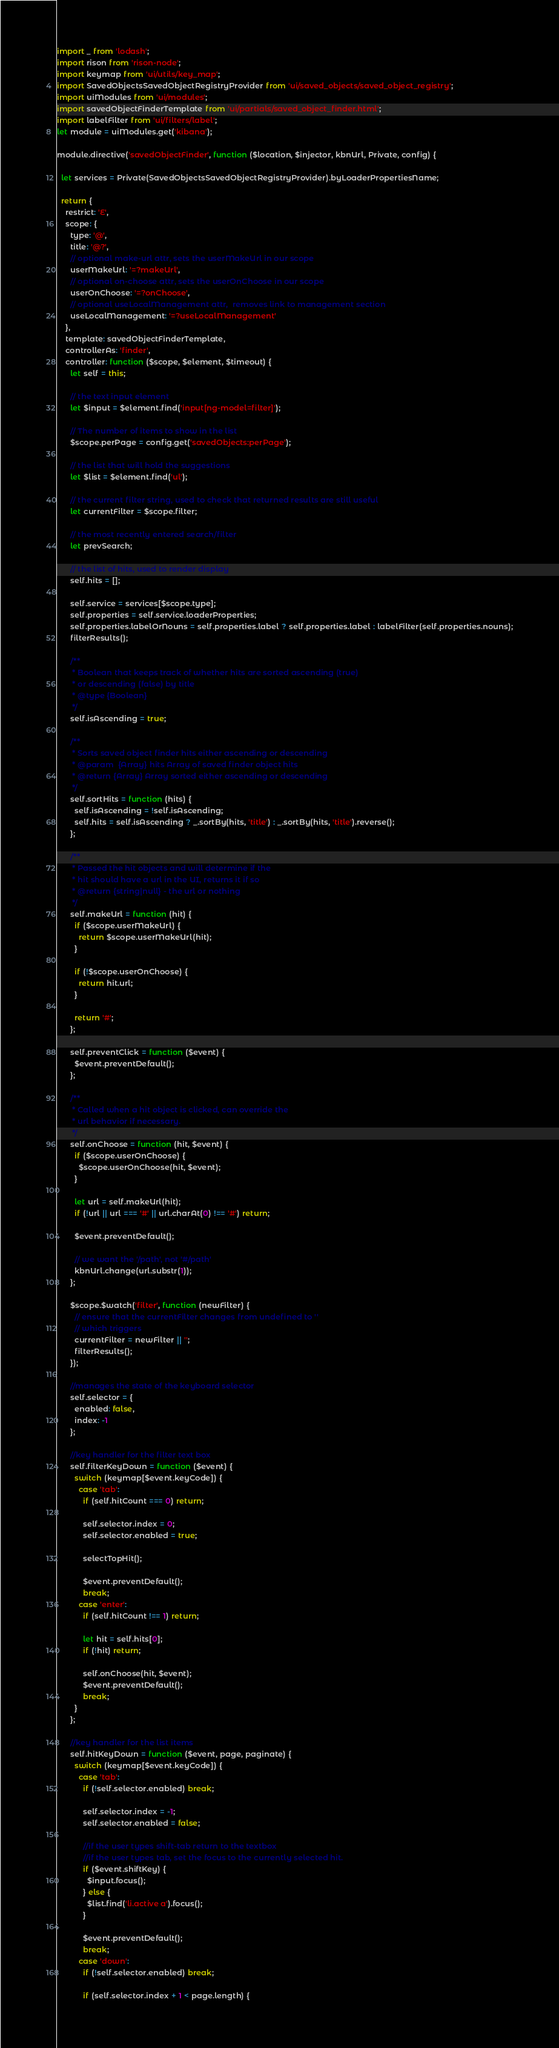<code> <loc_0><loc_0><loc_500><loc_500><_JavaScript_>import _ from 'lodash';
import rison from 'rison-node';
import keymap from 'ui/utils/key_map';
import SavedObjectsSavedObjectRegistryProvider from 'ui/saved_objects/saved_object_registry';
import uiModules from 'ui/modules';
import savedObjectFinderTemplate from 'ui/partials/saved_object_finder.html';
import labelFilter from 'ui/filters/label';
let module = uiModules.get('kibana');

module.directive('savedObjectFinder', function ($location, $injector, kbnUrl, Private, config) {

  let services = Private(SavedObjectsSavedObjectRegistryProvider).byLoaderPropertiesName;

  return {
    restrict: 'E',
    scope: {
      type: '@',
      title: '@?',
      // optional make-url attr, sets the userMakeUrl in our scope
      userMakeUrl: '=?makeUrl',
      // optional on-choose attr, sets the userOnChoose in our scope
      userOnChoose: '=?onChoose',
      // optional useLocalManagement attr,  removes link to management section
      useLocalManagement: '=?useLocalManagement'
    },
    template: savedObjectFinderTemplate,
    controllerAs: 'finder',
    controller: function ($scope, $element, $timeout) {
      let self = this;

      // the text input element
      let $input = $element.find('input[ng-model=filter]');

      // The number of items to show in the list
      $scope.perPage = config.get('savedObjects:perPage');

      // the list that will hold the suggestions
      let $list = $element.find('ul');

      // the current filter string, used to check that returned results are still useful
      let currentFilter = $scope.filter;

      // the most recently entered search/filter
      let prevSearch;

      // the list of hits, used to render display
      self.hits = [];

      self.service = services[$scope.type];
      self.properties = self.service.loaderProperties;
      self.properties.labelOrNouns = self.properties.label ? self.properties.label : labelFilter(self.properties.nouns);
      filterResults();

      /**
       * Boolean that keeps track of whether hits are sorted ascending (true)
       * or descending (false) by title
       * @type {Boolean}
       */
      self.isAscending = true;

      /**
       * Sorts saved object finder hits either ascending or descending
       * @param  {Array} hits Array of saved finder object hits
       * @return {Array} Array sorted either ascending or descending
       */
      self.sortHits = function (hits) {
        self.isAscending = !self.isAscending;
        self.hits = self.isAscending ? _.sortBy(hits, 'title') : _.sortBy(hits, 'title').reverse();
      };

      /**
       * Passed the hit objects and will determine if the
       * hit should have a url in the UI, returns it if so
       * @return {string|null} - the url or nothing
       */
      self.makeUrl = function (hit) {
        if ($scope.userMakeUrl) {
          return $scope.userMakeUrl(hit);
        }

        if (!$scope.userOnChoose) {
          return hit.url;
        }

        return '#';
      };

      self.preventClick = function ($event) {
        $event.preventDefault();
      };

      /**
       * Called when a hit object is clicked, can override the
       * url behavior if necessary.
       */
      self.onChoose = function (hit, $event) {
        if ($scope.userOnChoose) {
          $scope.userOnChoose(hit, $event);
        }

        let url = self.makeUrl(hit);
        if (!url || url === '#' || url.charAt(0) !== '#') return;

        $event.preventDefault();

        // we want the '/path', not '#/path'
        kbnUrl.change(url.substr(1));
      };

      $scope.$watch('filter', function (newFilter) {
        // ensure that the currentFilter changes from undefined to ''
        // which triggers
        currentFilter = newFilter || '';
        filterResults();
      });

      //manages the state of the keyboard selector
      self.selector = {
        enabled: false,
        index: -1
      };

      //key handler for the filter text box
      self.filterKeyDown = function ($event) {
        switch (keymap[$event.keyCode]) {
          case 'tab':
            if (self.hitCount === 0) return;

            self.selector.index = 0;
            self.selector.enabled = true;

            selectTopHit();

            $event.preventDefault();
            break;
          case 'enter':
            if (self.hitCount !== 1) return;

            let hit = self.hits[0];
            if (!hit) return;

            self.onChoose(hit, $event);
            $event.preventDefault();
            break;
        }
      };

      //key handler for the list items
      self.hitKeyDown = function ($event, page, paginate) {
        switch (keymap[$event.keyCode]) {
          case 'tab':
            if (!self.selector.enabled) break;

            self.selector.index = -1;
            self.selector.enabled = false;

            //if the user types shift-tab return to the textbox
            //if the user types tab, set the focus to the currently selected hit.
            if ($event.shiftKey) {
              $input.focus();
            } else {
              $list.find('li.active a').focus();
            }

            $event.preventDefault();
            break;
          case 'down':
            if (!self.selector.enabled) break;

            if (self.selector.index + 1 < page.length) {</code> 